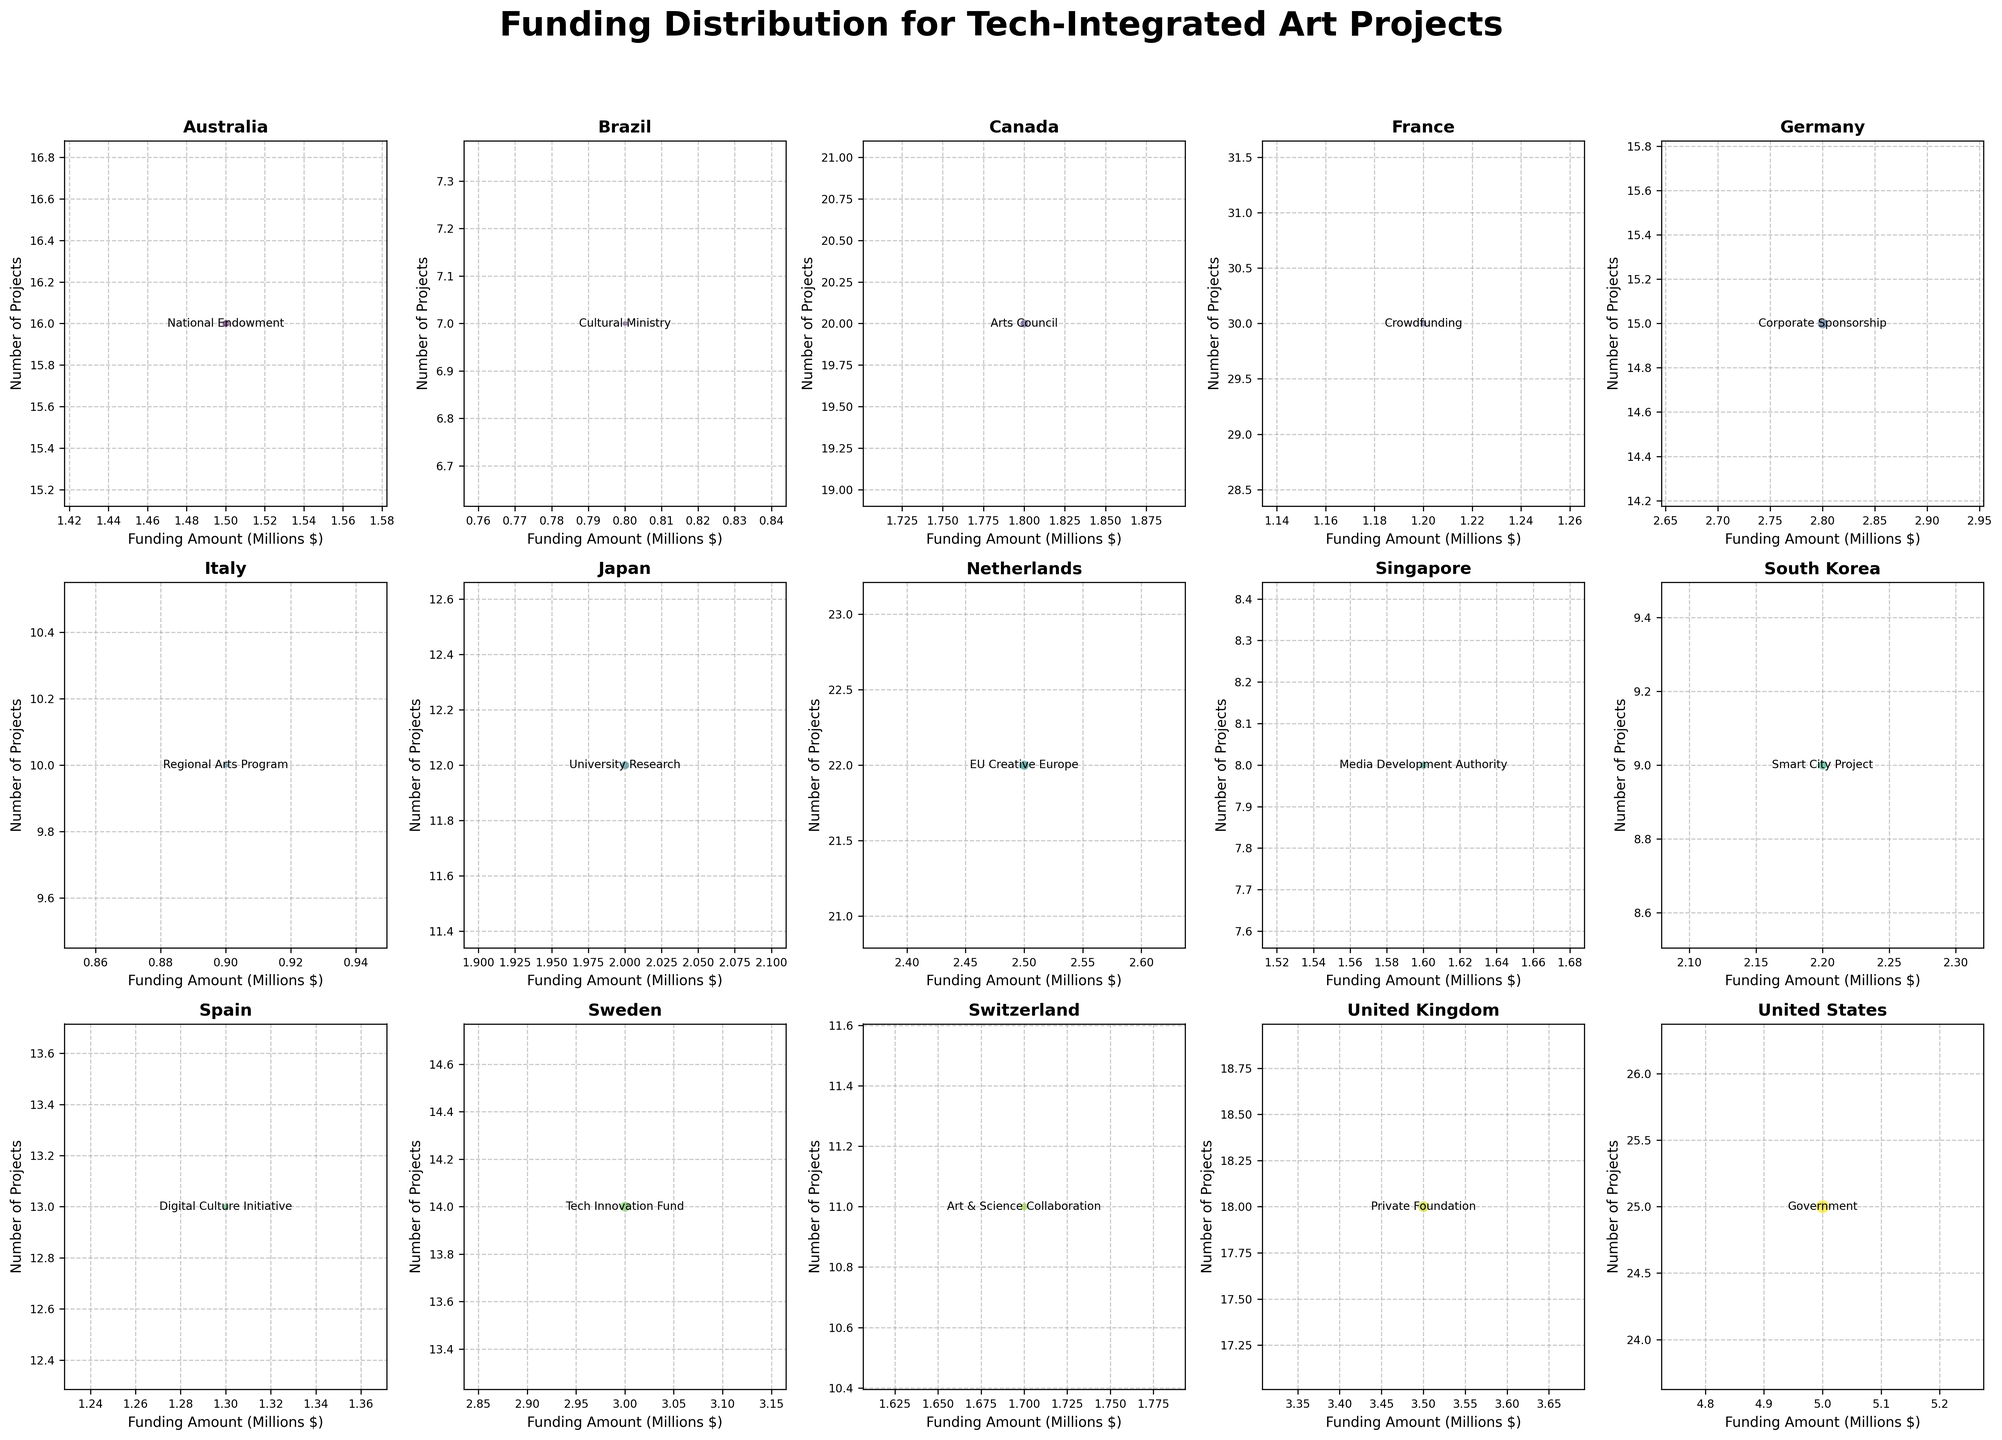What is the title of the figure? The title of the figure can be found at the top center of the subplot. It is usually written in a larger and bolder font to make it stand out.
Answer: Funding Distribution for Tech-Integrated Art Projects Which country has the highest number of projects? In each subplot, the y-axis represents the number of projects. By comparing the highest y-values across all subplots, we see that France has the highest number of projects at 30.
Answer: France What is the total funding amount for art projects in the United States? Check the subplot titled "United States" and look at the x-axis which represents the funding amount converted to millions. The funding amount for the US is shown as 5, which means $5,000,000.
Answer: $5,000,000 Which grant type is noted in the Netherlands' subplot? To identify the grant type for the Netherlands, look within the subplot titled "Netherlands". The annotated text shows the grant type for this country.
Answer: EU Creative Europe Compare the number of projects in the United Kingdom and Japan; which has more? Look at the subplots for the United Kingdom and Japan and compare their y-axes' values representing the number of projects. The United Kingdom has 18 projects, whereas Japan has 12 projects.
Answer: United Kingdom How many countries have more than 20 projects? Count the subplots where the y-axis value exceeds 20. The countries satisfying this criterion are the United States (25), France (30), Canada (20), and the Netherlands (22). This makes a total of four countries.
Answer: 4 What is the range of funding amounts in millions across all countries? Identify the minimum and maximum values on the x-axis of all subplots. The lowest is the funding amount for Italy, approximately $0.9 million, and the highest for the United States at $5 million. Hence, the range is $5 million - $0.9 million = $4.1 million.
Answer: $4.1 million Which country has the largest bubble size in its subplot? The bubble size in each subplot is proportional to the funding amount. Examine all the bubbles and find that the United States' bubble is the largest, indicating the highest funding.
Answer: United States Compare the grant type funding amounts for Brazil and Spain. Which country has more funding? Look at the subplots for Brazil and Spain, using the x-axis values as indicators of funding amounts grown in millions. Brazil has approximately $0.8 million, and Spain has $1.3 million. Spain has more funding.
Answer: Spain 